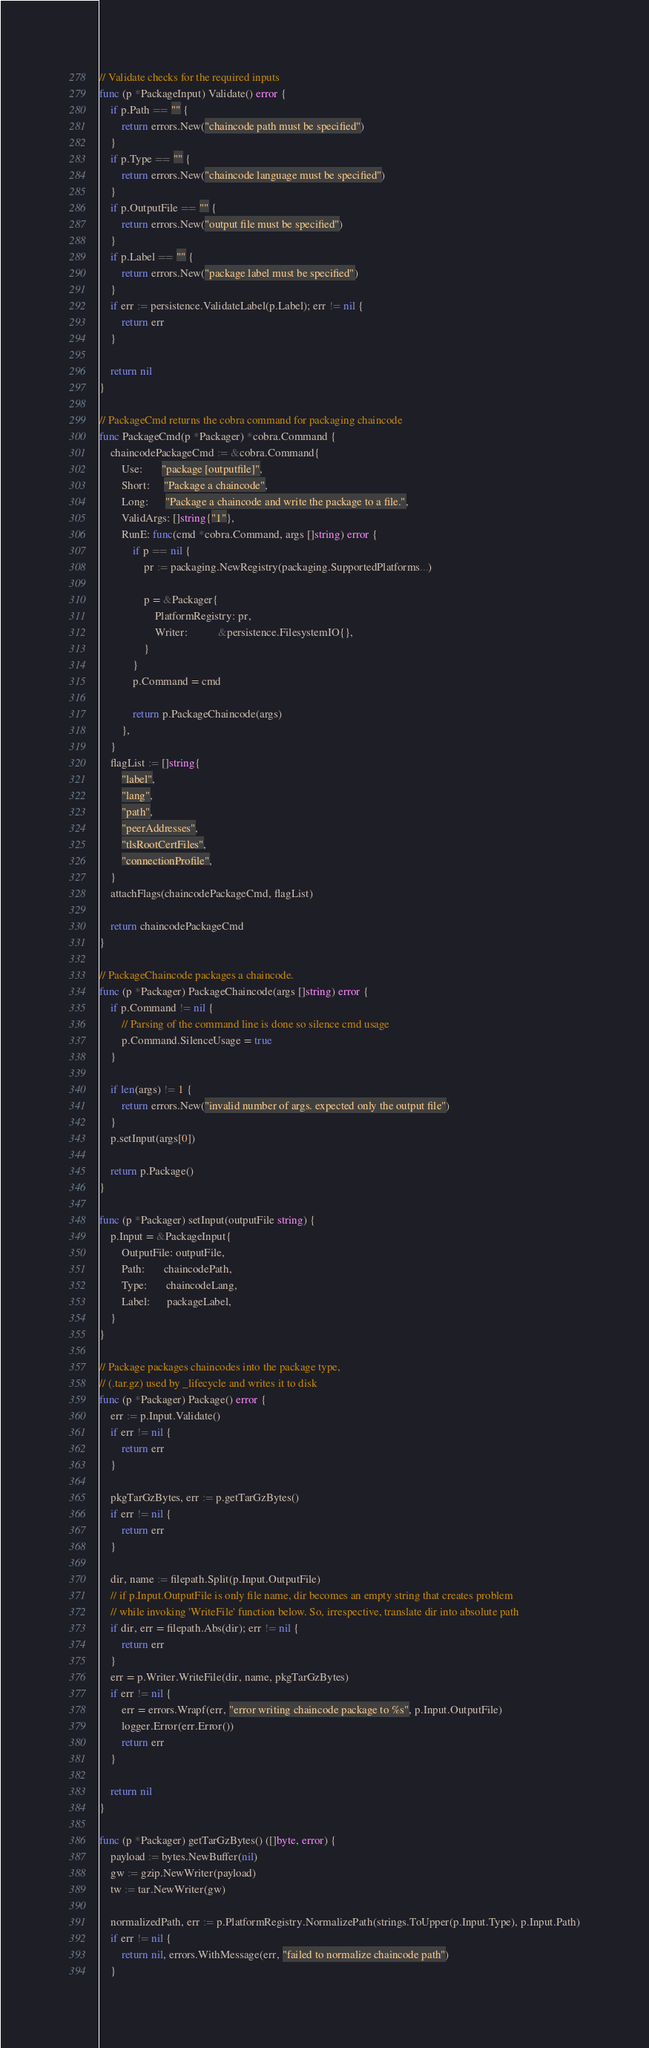Convert code to text. <code><loc_0><loc_0><loc_500><loc_500><_Go_>
// Validate checks for the required inputs
func (p *PackageInput) Validate() error {
	if p.Path == "" {
		return errors.New("chaincode path must be specified")
	}
	if p.Type == "" {
		return errors.New("chaincode language must be specified")
	}
	if p.OutputFile == "" {
		return errors.New("output file must be specified")
	}
	if p.Label == "" {
		return errors.New("package label must be specified")
	}
	if err := persistence.ValidateLabel(p.Label); err != nil {
		return err
	}

	return nil
}

// PackageCmd returns the cobra command for packaging chaincode
func PackageCmd(p *Packager) *cobra.Command {
	chaincodePackageCmd := &cobra.Command{
		Use:       "package [outputfile]",
		Short:     "Package a chaincode",
		Long:      "Package a chaincode and write the package to a file.",
		ValidArgs: []string{"1"},
		RunE: func(cmd *cobra.Command, args []string) error {
			if p == nil {
				pr := packaging.NewRegistry(packaging.SupportedPlatforms...)

				p = &Packager{
					PlatformRegistry: pr,
					Writer:           &persistence.FilesystemIO{},
				}
			}
			p.Command = cmd

			return p.PackageChaincode(args)
		},
	}
	flagList := []string{
		"label",
		"lang",
		"path",
		"peerAddresses",
		"tlsRootCertFiles",
		"connectionProfile",
	}
	attachFlags(chaincodePackageCmd, flagList)

	return chaincodePackageCmd
}

// PackageChaincode packages a chaincode.
func (p *Packager) PackageChaincode(args []string) error {
	if p.Command != nil {
		// Parsing of the command line is done so silence cmd usage
		p.Command.SilenceUsage = true
	}

	if len(args) != 1 {
		return errors.New("invalid number of args. expected only the output file")
	}
	p.setInput(args[0])

	return p.Package()
}

func (p *Packager) setInput(outputFile string) {
	p.Input = &PackageInput{
		OutputFile: outputFile,
		Path:       chaincodePath,
		Type:       chaincodeLang,
		Label:      packageLabel,
	}
}

// Package packages chaincodes into the package type,
// (.tar.gz) used by _lifecycle and writes it to disk
func (p *Packager) Package() error {
	err := p.Input.Validate()
	if err != nil {
		return err
	}

	pkgTarGzBytes, err := p.getTarGzBytes()
	if err != nil {
		return err
	}

	dir, name := filepath.Split(p.Input.OutputFile)
	// if p.Input.OutputFile is only file name, dir becomes an empty string that creates problem
	// while invoking 'WriteFile' function below. So, irrespective, translate dir into absolute path
	if dir, err = filepath.Abs(dir); err != nil {
		return err
	}
	err = p.Writer.WriteFile(dir, name, pkgTarGzBytes)
	if err != nil {
		err = errors.Wrapf(err, "error writing chaincode package to %s", p.Input.OutputFile)
		logger.Error(err.Error())
		return err
	}

	return nil
}

func (p *Packager) getTarGzBytes() ([]byte, error) {
	payload := bytes.NewBuffer(nil)
	gw := gzip.NewWriter(payload)
	tw := tar.NewWriter(gw)

	normalizedPath, err := p.PlatformRegistry.NormalizePath(strings.ToUpper(p.Input.Type), p.Input.Path)
	if err != nil {
		return nil, errors.WithMessage(err, "failed to normalize chaincode path")
	}</code> 